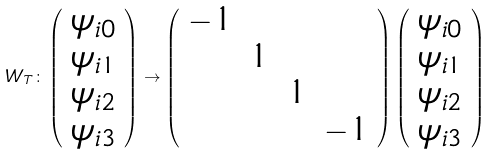Convert formula to latex. <formula><loc_0><loc_0><loc_500><loc_500>W _ { T } \colon \left ( \begin{array} { c } \psi _ { i 0 } \\ \psi _ { i 1 } \\ \psi _ { i 2 } \\ \psi _ { i 3 } \end{array} \right ) \rightarrow \left ( \begin{array} { c c c c } - 1 & & & \\ & 1 & & \\ & & 1 & \\ & & & - 1 \end{array} \right ) \left ( \begin{array} { c } \psi _ { i 0 } \\ \psi _ { i 1 } \\ \psi _ { i 2 } \\ \psi _ { i 3 } \end{array} \right )</formula> 